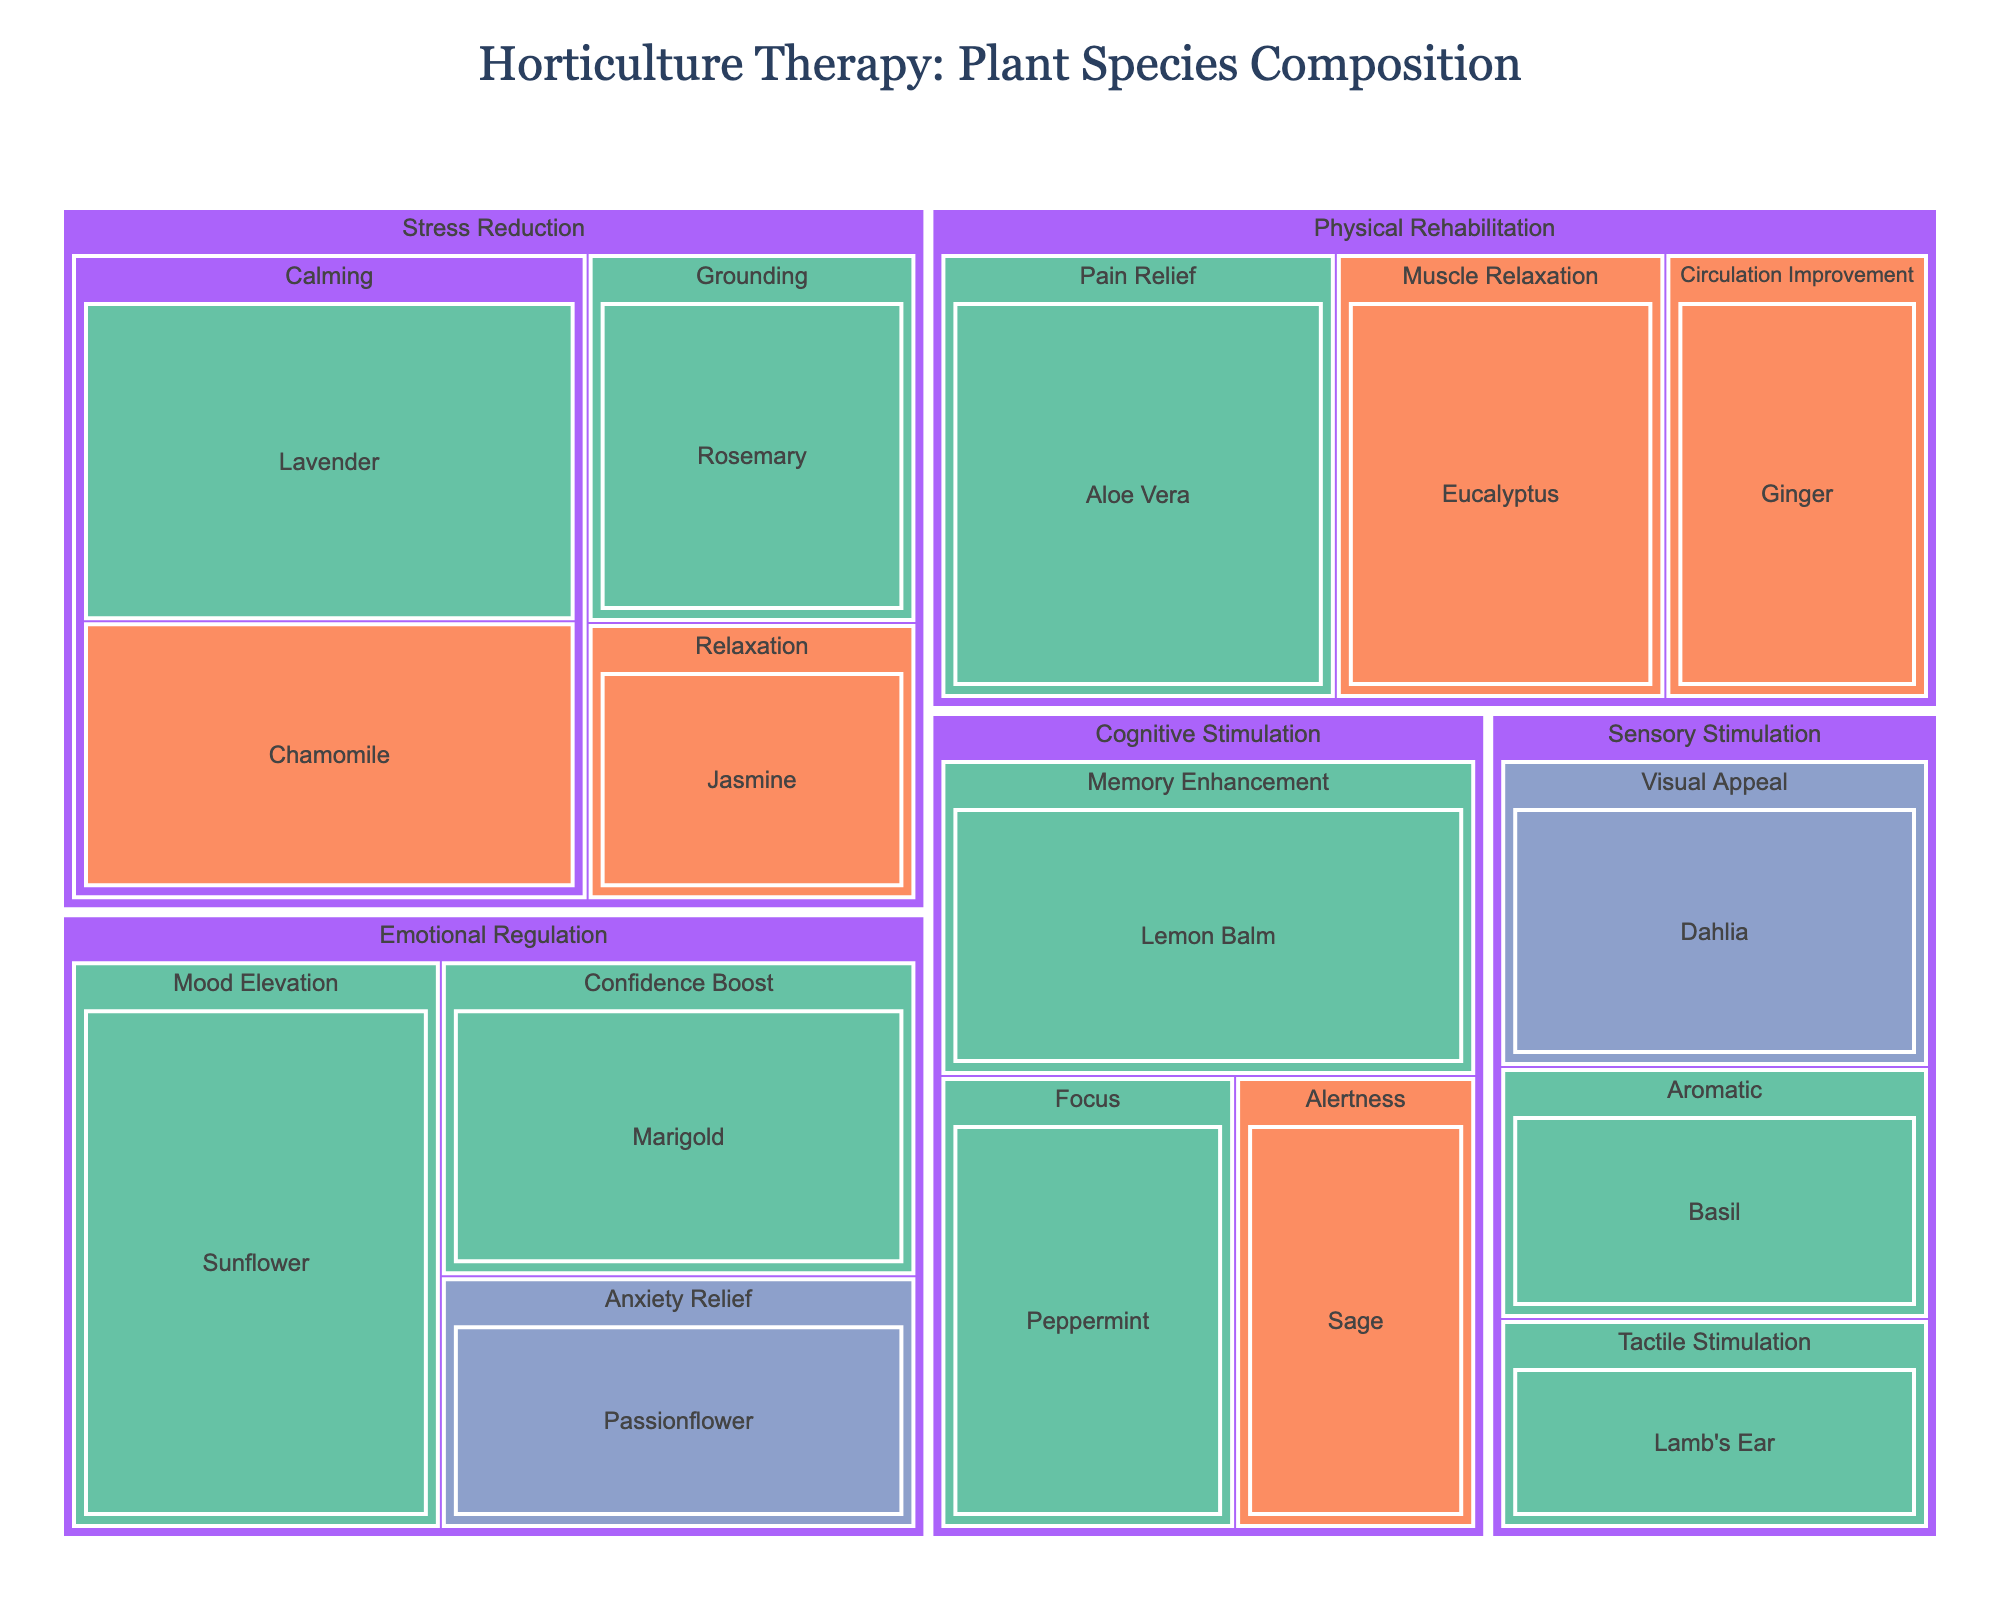What is the title of the treemap? The title of the treemap is displayed at the top of the figure and is easy to locate.
Answer: Horticulture Therapy: Plant Species Composition Which plant species are used in the Emotional Regulation category? In the treemap, locate the Emotional Regulation category, then look at the plant species listed under it.
Answer: Sunflower, Passionflower, Marigold What is the total value of plant species in the Stress Reduction category? Locate all the plant species under the Stress Reduction category. Sum their values. (30 + 25 + 20 + 15) = 90
Answer: 90 Which plant species related to Cognitive Stimulation has the highest value? Find the Cognitive Stimulation category and compare the values of each plant species within it. Lemon Balm has the highest value of 28.
Answer: Lemon Balm What color represents plants that are easy to cultivate? Look at the figure's legend or the color scale indicating cultivation ease. Observe the corresponding color for 'Easy.'
Answer: Green (#66c2a5) How many plant species are classified as providing Calming benefits? Locate the Calming benefit under the Stress Reduction category and count the plant species listed there.
Answer: 2 Which therapeutic benefit in the Physical Rehabilitation category has the highest value? Locate the Physical Rehabilitation category and compare the values of each therapeutic benefit under it. Pain Relief has the highest value at 30.
Answer: Pain Relief Between Cognitive Stimulation and Sensory Stimulation, which category has a larger total value of plant species? Sum the values of plant species in the Cognitive Stimulation category (28 + 22 + 18 = 68) and Sensory Stimulation category (18 + 22 + 15 = 55). Compare the sums.
Answer: Cognitive Stimulation How does the number of plant species with 'Moderate' cultivation ease compare to those with 'Difficult' cultivation ease? Count the number of plant species marked as 'Moderate' and compare this count to those marked as 'Difficult.' Moderate: 5 (Chamomile, Jasmine, Sage, Eucalyptus, Ginger), Difficult: 2 (Passionflower, Dahlia).
Answer: More with Moderate What is the average value of plant species categorized under Emotional Regulation? Sum the values of plant species in the Emotional Regulation category and divide by the number of species. (35 + 20 + 25) / 3 = 26.67
Answer: 26.67 